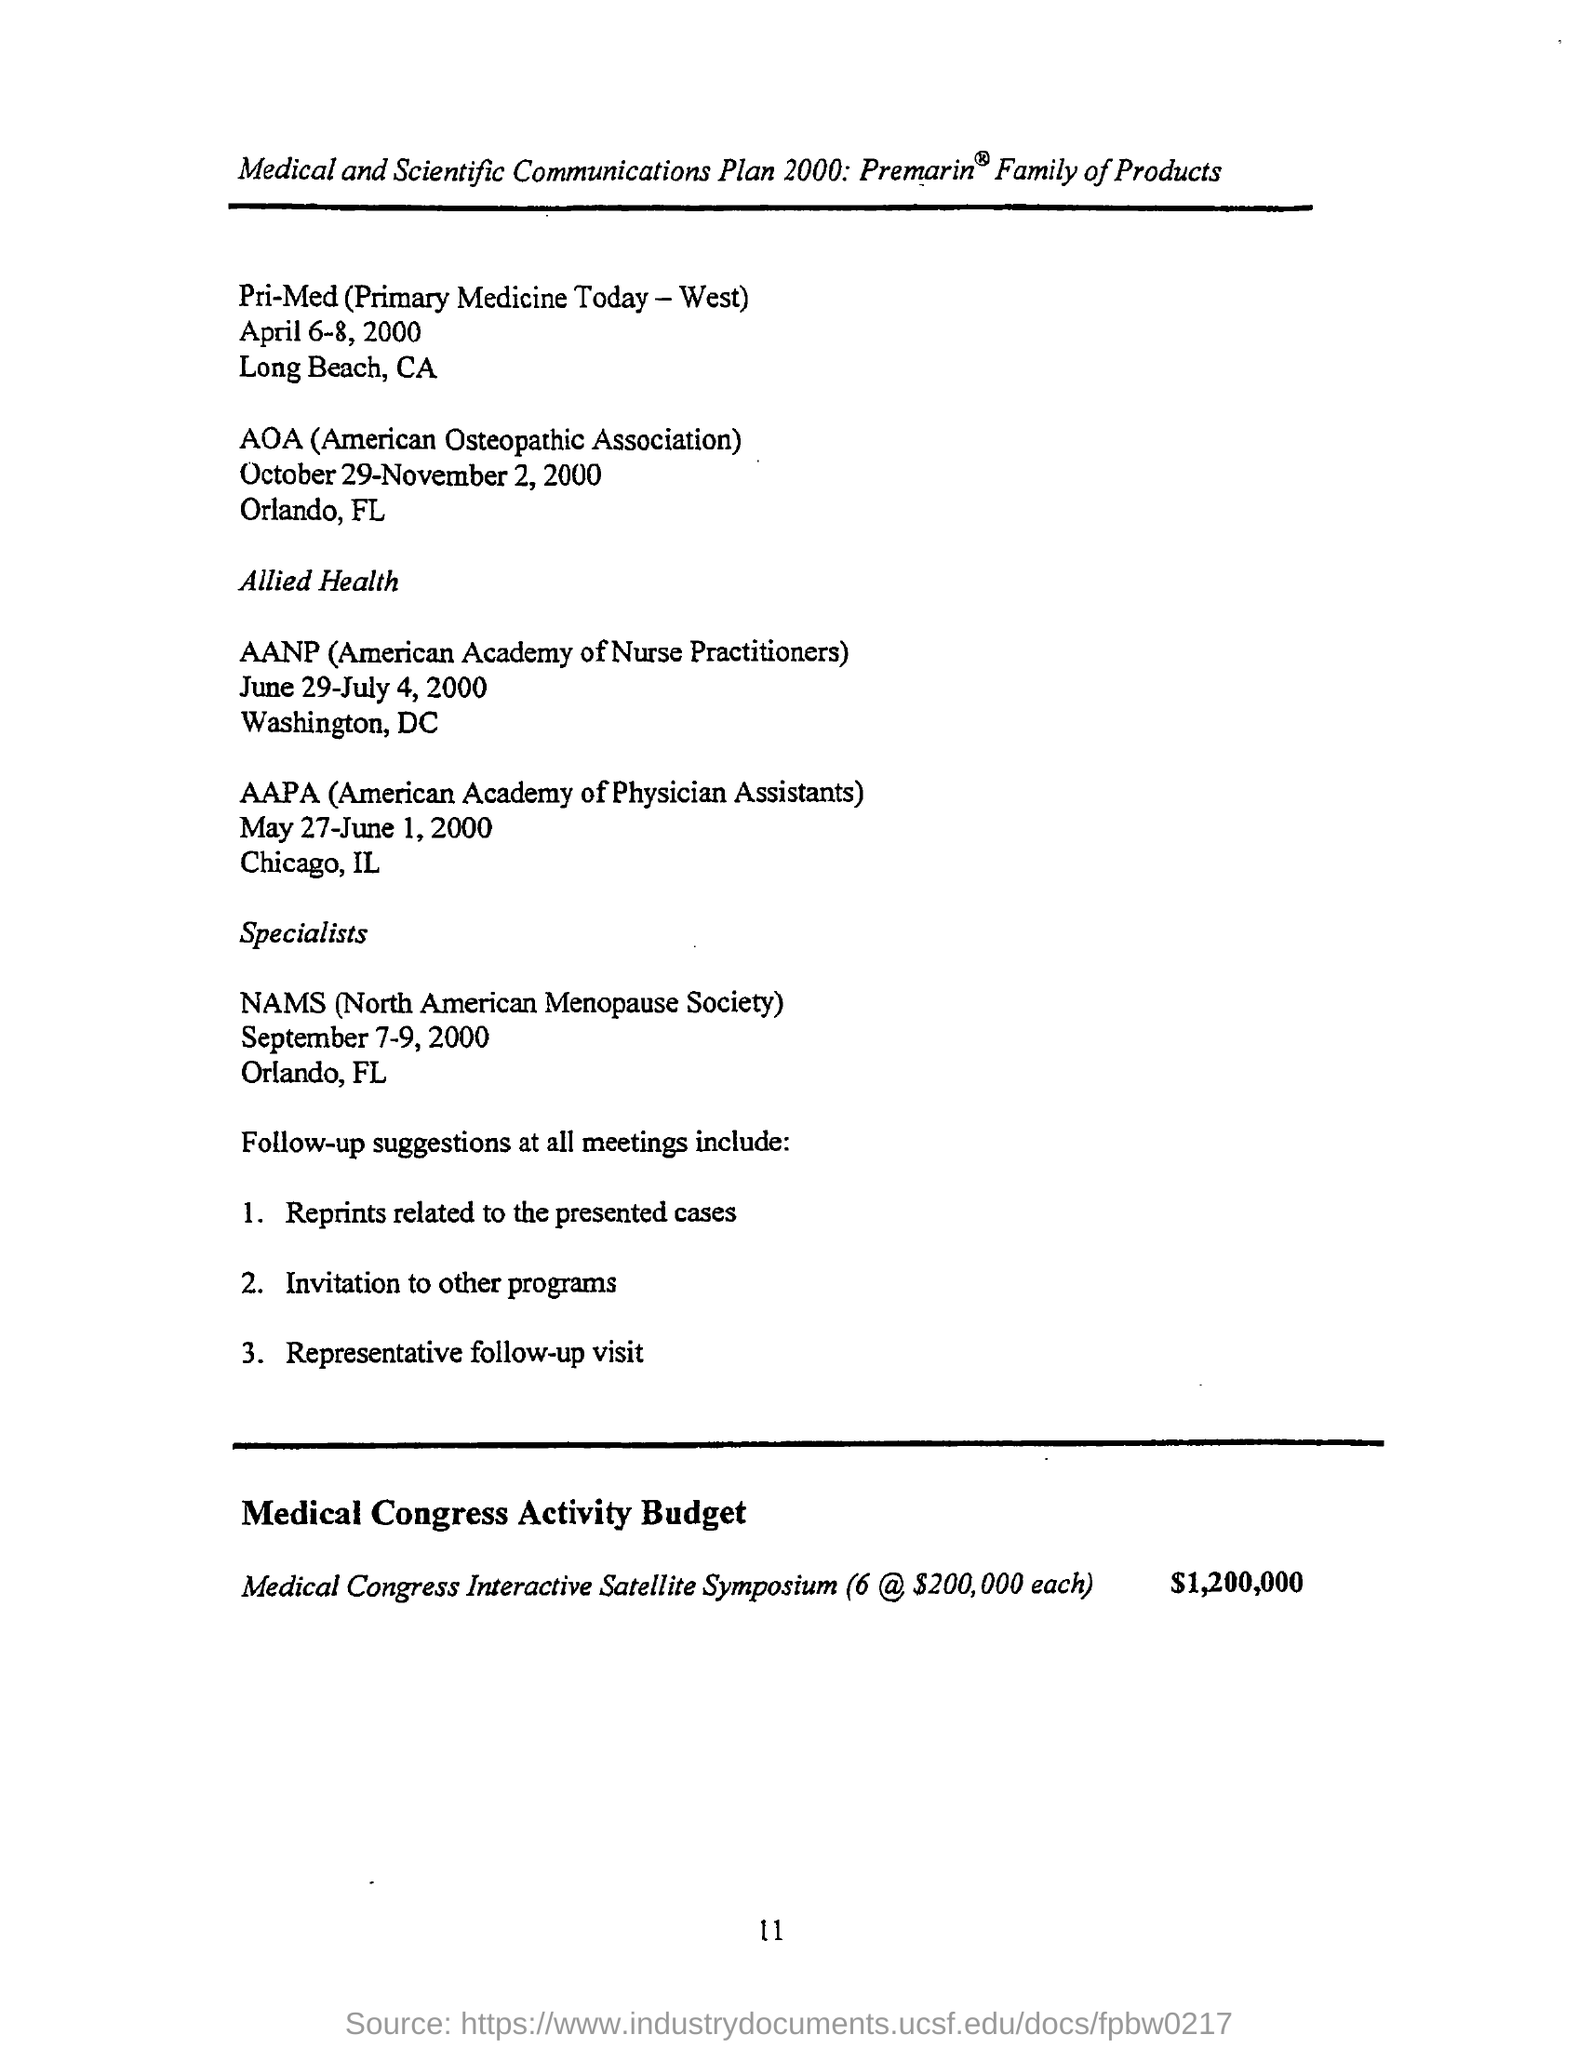What is the full form of aoa ?
Offer a very short reply. American Osteopathic Association. What is the full form of nams ?
Your response must be concise. North American Menopause Society. Where was the nams meeting held ?
Offer a very short reply. Orlando ,FL. 